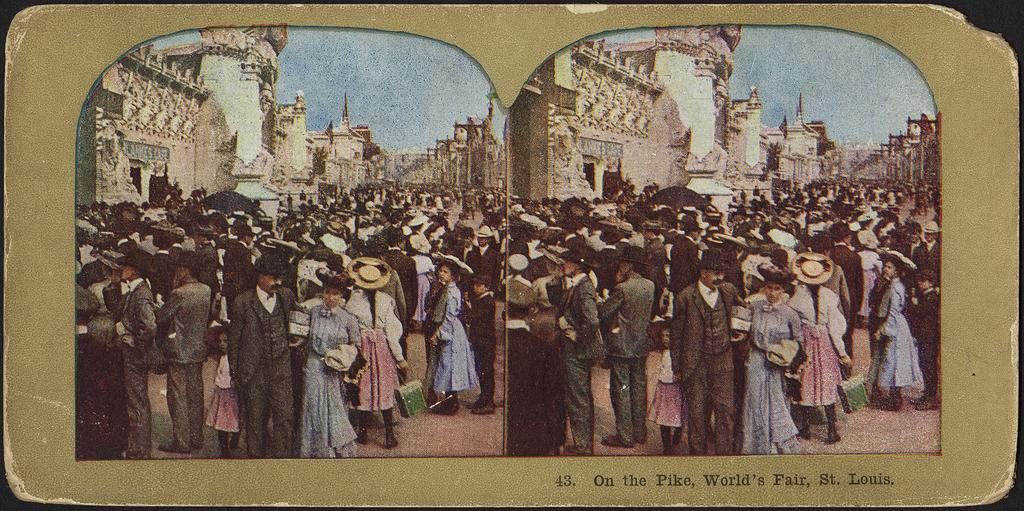What city name is mentioned at the bottom?
Keep it short and to the point. St louis. What number is at the bottom?
Your response must be concise. 43. 